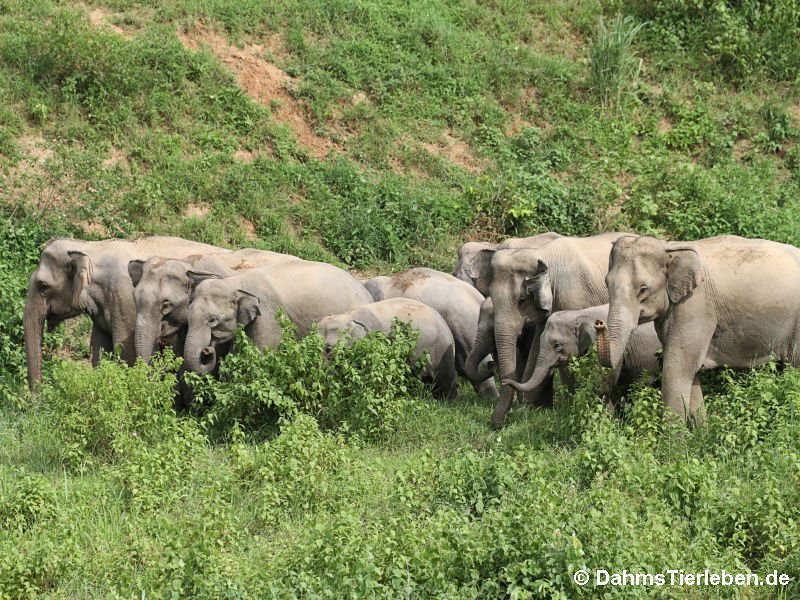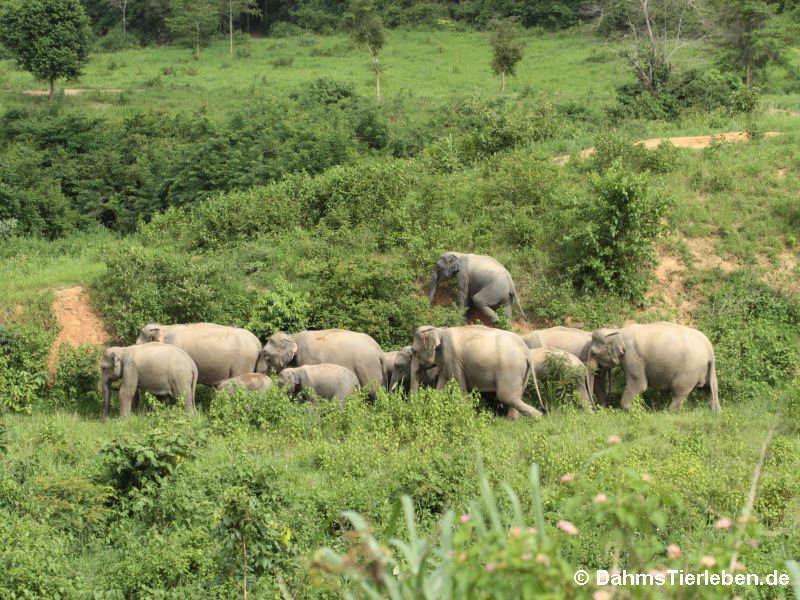The first image is the image on the left, the second image is the image on the right. Considering the images on both sides, is "A water hole is present in a scene with multiple elephants of different ages." valid? Answer yes or no. No. The first image is the image on the left, the second image is the image on the right. Analyze the images presented: Is the assertion "Elephants are standing in or beside water in the right image." valid? Answer yes or no. No. 